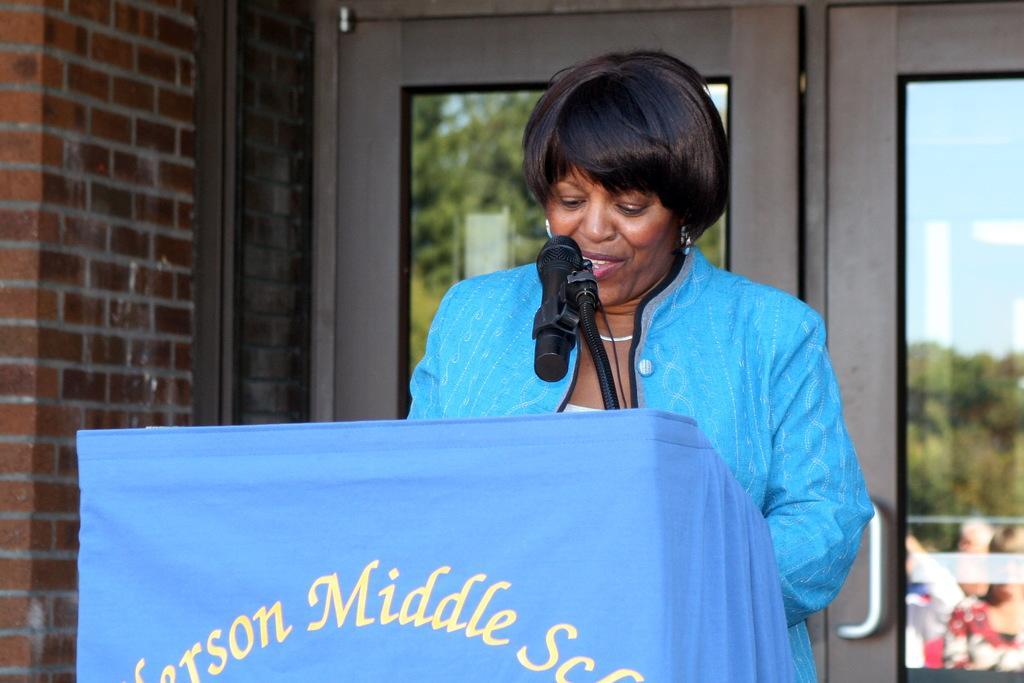Could you give a brief overview of what you see in this image? In this image, we can see a woman is standing behind the podium and talking in-front of a microphone. Here we can see podium covered with cloth. On the cloth we can see some text. Background we can see glass doors, brick wall. On the glass doors, we can see reflections. Here we can see trees, sky and few people. Here there is a holder. 